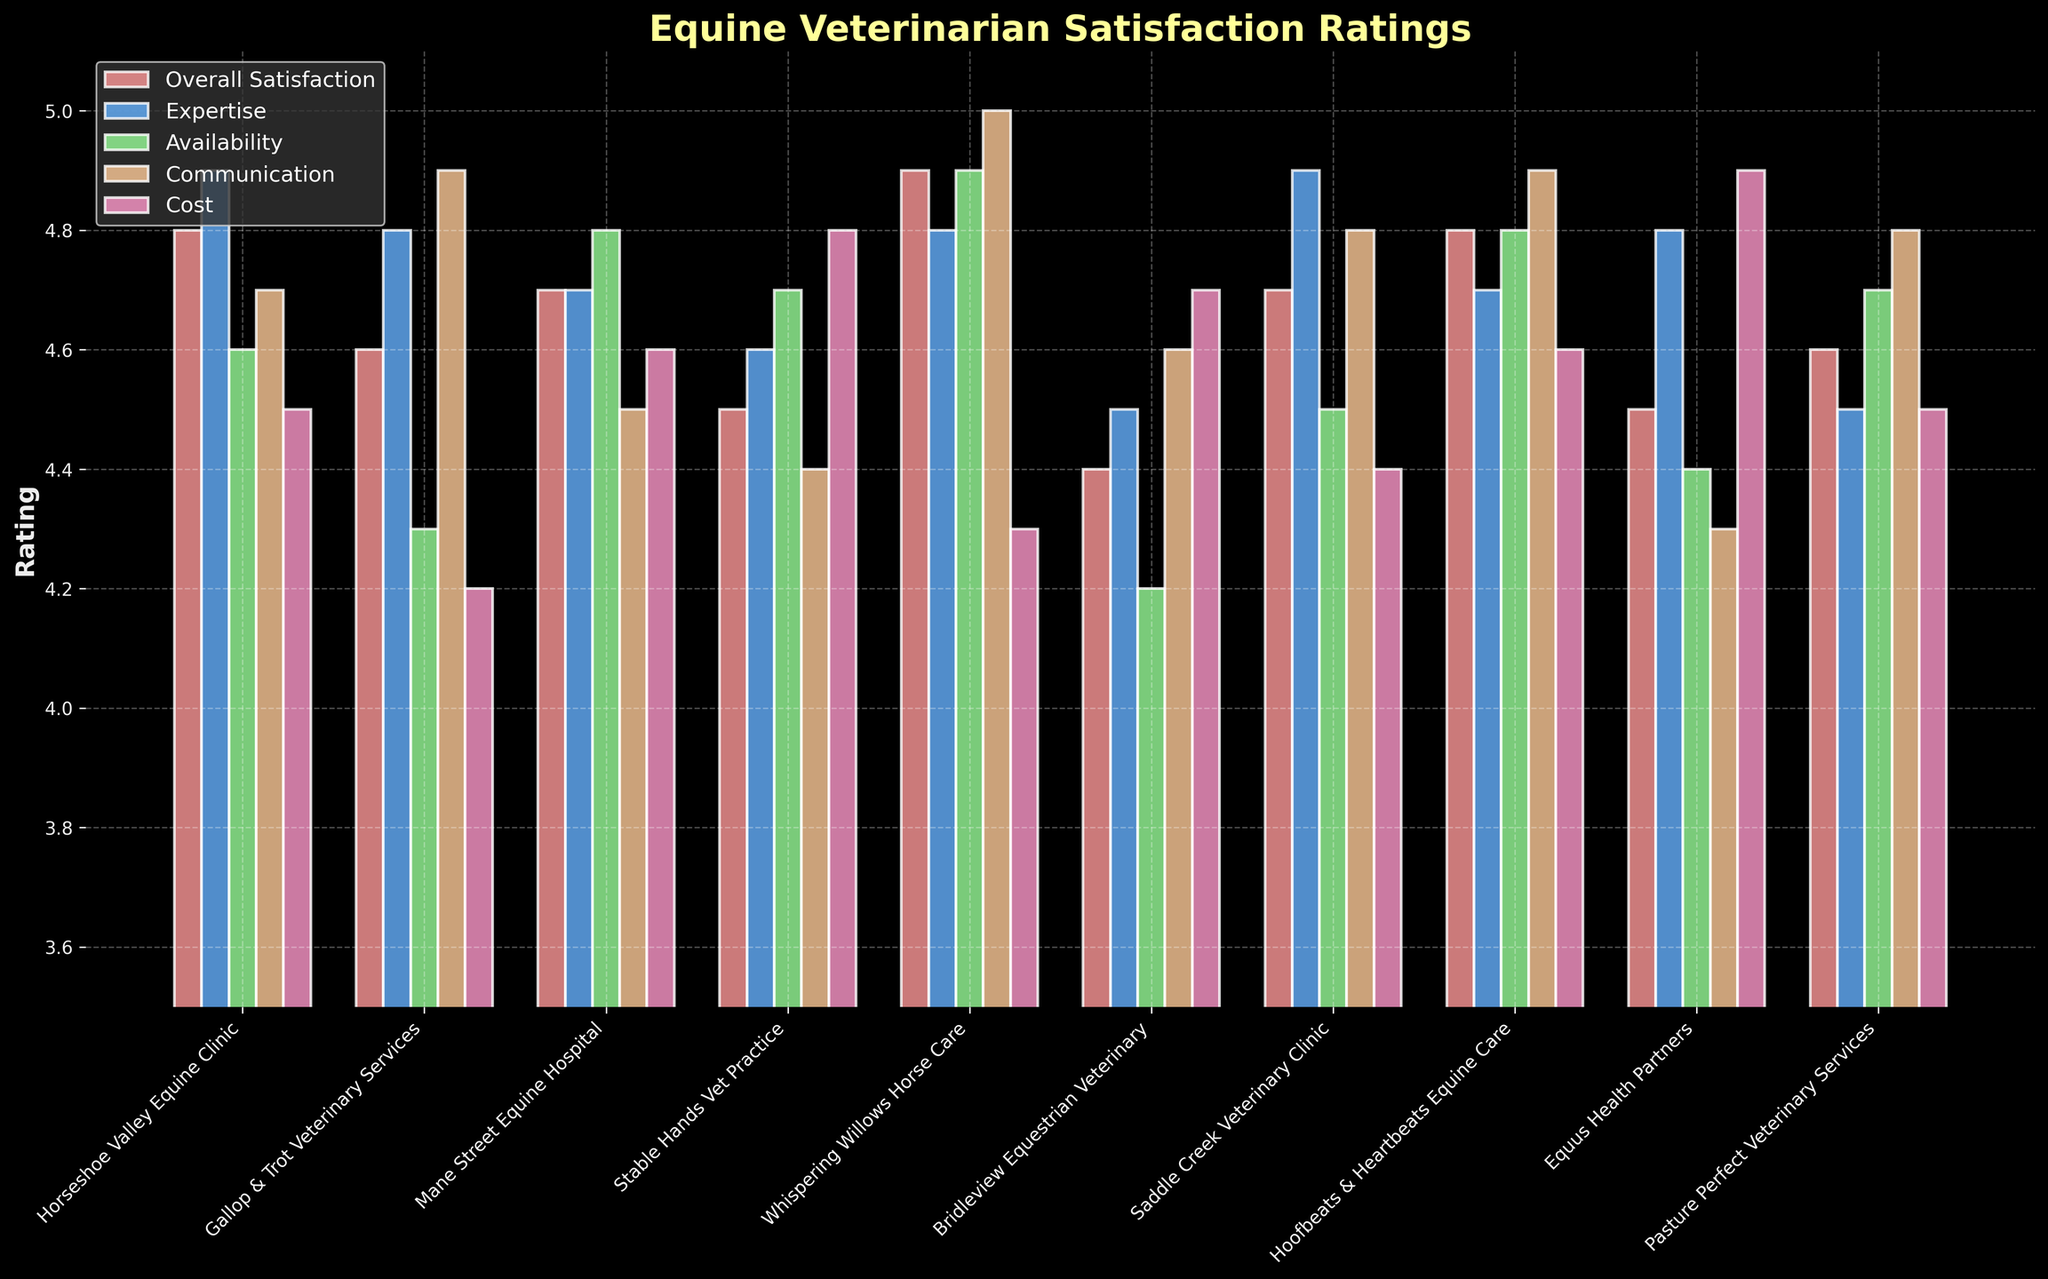Which veterinarian scores the highest in Communication? The Communication scores of each veterinarian are visually represented by different bars with specific heights. Whispering Willows Horse Care has the tallest bar in the Communication category, indicating the highest score.
Answer: Whispering Willows Horse Care What is the difference between the Cost rating of Equus Health Partners and Bridleview Equestrian Veterinary? The Cost rating for Equus Health Partners is 4.9 and for Bridleview Equestrian Veterinary is 4.7. The difference is calculated as 4.9 - 4.7 = 0.2.
Answer: 0.2 Which veterinarian has the highest Overall Satisfaction rating, and what is the value? By examining the heights of the bars corresponding to Overall Satisfaction, the highest bar is seen for Whispering Willows Horse Care, with a value of 4.9.
Answer: Whispering Willows Horse Care, 4.9 Compare the Availability ratings of Mane Street Equine Hospital and Pasture Perfect Veterinary Services. Which one is higher? The Availability rating of Mane Street Equine Hospital is 4.8, while Pasture Perfect Veterinary Services has an Availability rating of 4.7. Therefore, Mane Street Equine Hospital has a higher Availability rating.
Answer: Mane Street Equine Hospital Which veterinarian has the lowest rating in the Expertise category and what is that rating? Among the bars representing the Expertise category, the lowest bar corresponds to Bridleview Equestrian Veterinary, with a rating of 4.5.
Answer: Bridleview Equestrian Veterinary, 4.5 What's the average Cost rating across all veterinarians? Sum of the Cost ratings of all veterinarians: 4.5 + 4.2 + 4.6 + 4.8 + 4.3 + 4.7 + 4.4 + 4.6 + 4.9 + 4.5 = 45.5. There are 10 veterinarians, so the average is 45.5 / 10 = 4.55.
Answer: 4.55 Which veterinarian shows the least variation between their highest and lowest ratings? Calculate the range (difference between the highest and lowest ratings) for each veterinarian. The veterinarian with the smallest range is Stable Hands Vet Practice, with a range from 4.4 (Communication) to 4.8 (Cost), which is 0.4.
Answer: Stable Hands Vet Practice What is the combined sum of the Overall Satisfaction ratings for Saddle Creek Veterinary Clinic and Hoofbeats & Heartbeats Equine Care? The Overall Satisfaction rating for Saddle Creek Veterinary Clinic is 4.7, and for Hoofbeats & Heartbeats Equine Care, it is 4.8. Their combined sum is 4.7 + 4.8 = 9.5.
Answer: 9.5 Which criterion did Gallop & Trot Veterinary Services score highest in? For Gallop & Trot Veterinary Services, the highest rating among the criteria is in Communication, where they scored 4.9.
Answer: Communication Compare the Overall Satisfaction and Communication ratings for Horseshoe Valley Equine Clinic. Which one is higher? The Overall Satisfaction rating for Horseshoe Valley Equine Clinic is 4.8, while the Communication rating is 4.7. Thus, the Overall Satisfaction rating is higher.
Answer: Overall Satisfaction 